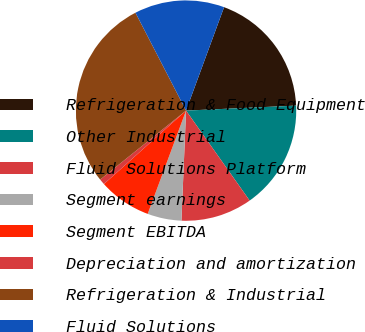<chart> <loc_0><loc_0><loc_500><loc_500><pie_chart><fcel>Refrigeration & Food Equipment<fcel>Other Industrial<fcel>Fluid Solutions Platform<fcel>Segment earnings<fcel>Segment EBITDA<fcel>Depreciation and amortization<fcel>Refrigeration & Industrial<fcel>Fluid Solutions<nl><fcel>18.67%<fcel>15.93%<fcel>10.46%<fcel>4.99%<fcel>7.73%<fcel>0.84%<fcel>28.18%<fcel>13.2%<nl></chart> 